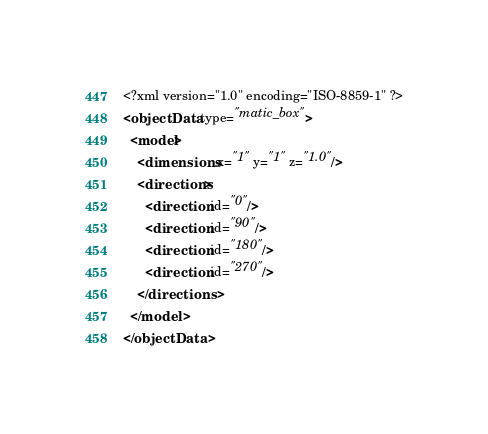<code> <loc_0><loc_0><loc_500><loc_500><_XML_><?xml version="1.0" encoding="ISO-8859-1" ?>
<objectData type="matic_box">
  <model>
    <dimensions x="1" y="1" z="1.0"/>
    <directions>
      <direction id="0"/>
      <direction id="90"/>
      <direction id="180"/>
      <direction id="270"/>
    </directions>
  </model>
</objectData></code> 